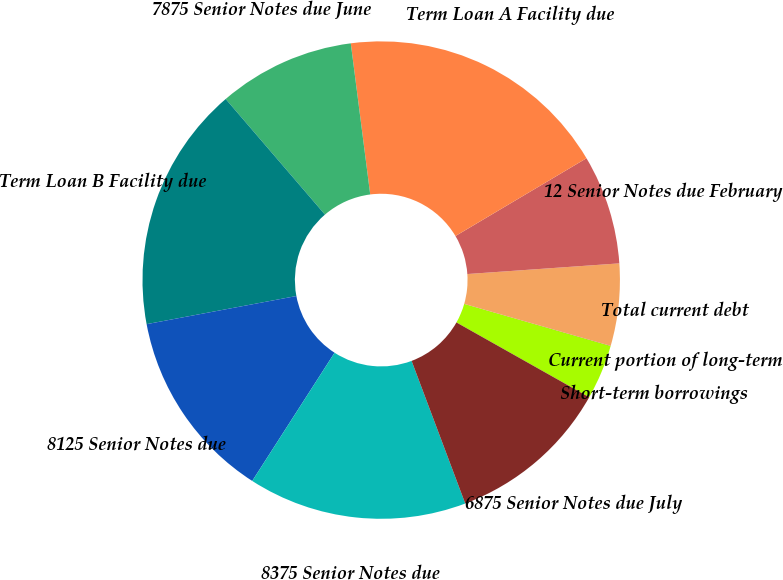<chart> <loc_0><loc_0><loc_500><loc_500><pie_chart><fcel>Short-term borrowings<fcel>Current portion of long-term<fcel>Total current debt<fcel>12 Senior Notes due February<fcel>Term Loan A Facility due<fcel>7875 Senior Notes due June<fcel>Term Loan B Facility due<fcel>8125 Senior Notes due<fcel>8375 Senior Notes due<fcel>6875 Senior Notes due July<nl><fcel>3.71%<fcel>0.01%<fcel>5.56%<fcel>7.41%<fcel>18.51%<fcel>9.26%<fcel>16.66%<fcel>12.96%<fcel>14.81%<fcel>11.11%<nl></chart> 